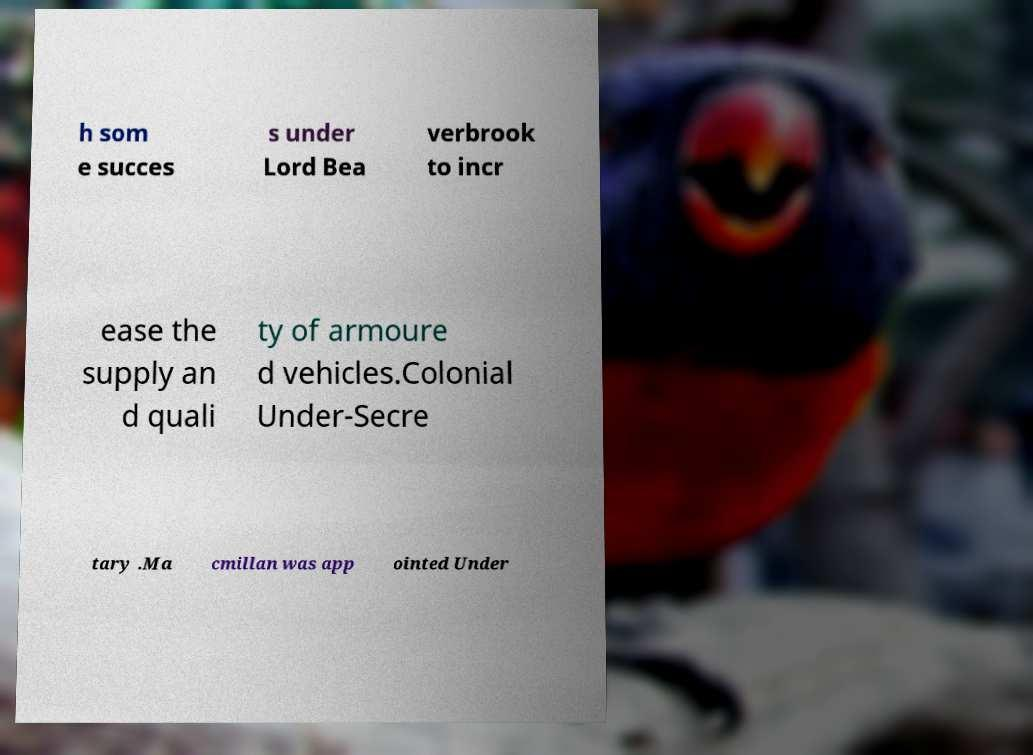Could you extract and type out the text from this image? h som e succes s under Lord Bea verbrook to incr ease the supply an d quali ty of armoure d vehicles.Colonial Under-Secre tary .Ma cmillan was app ointed Under 